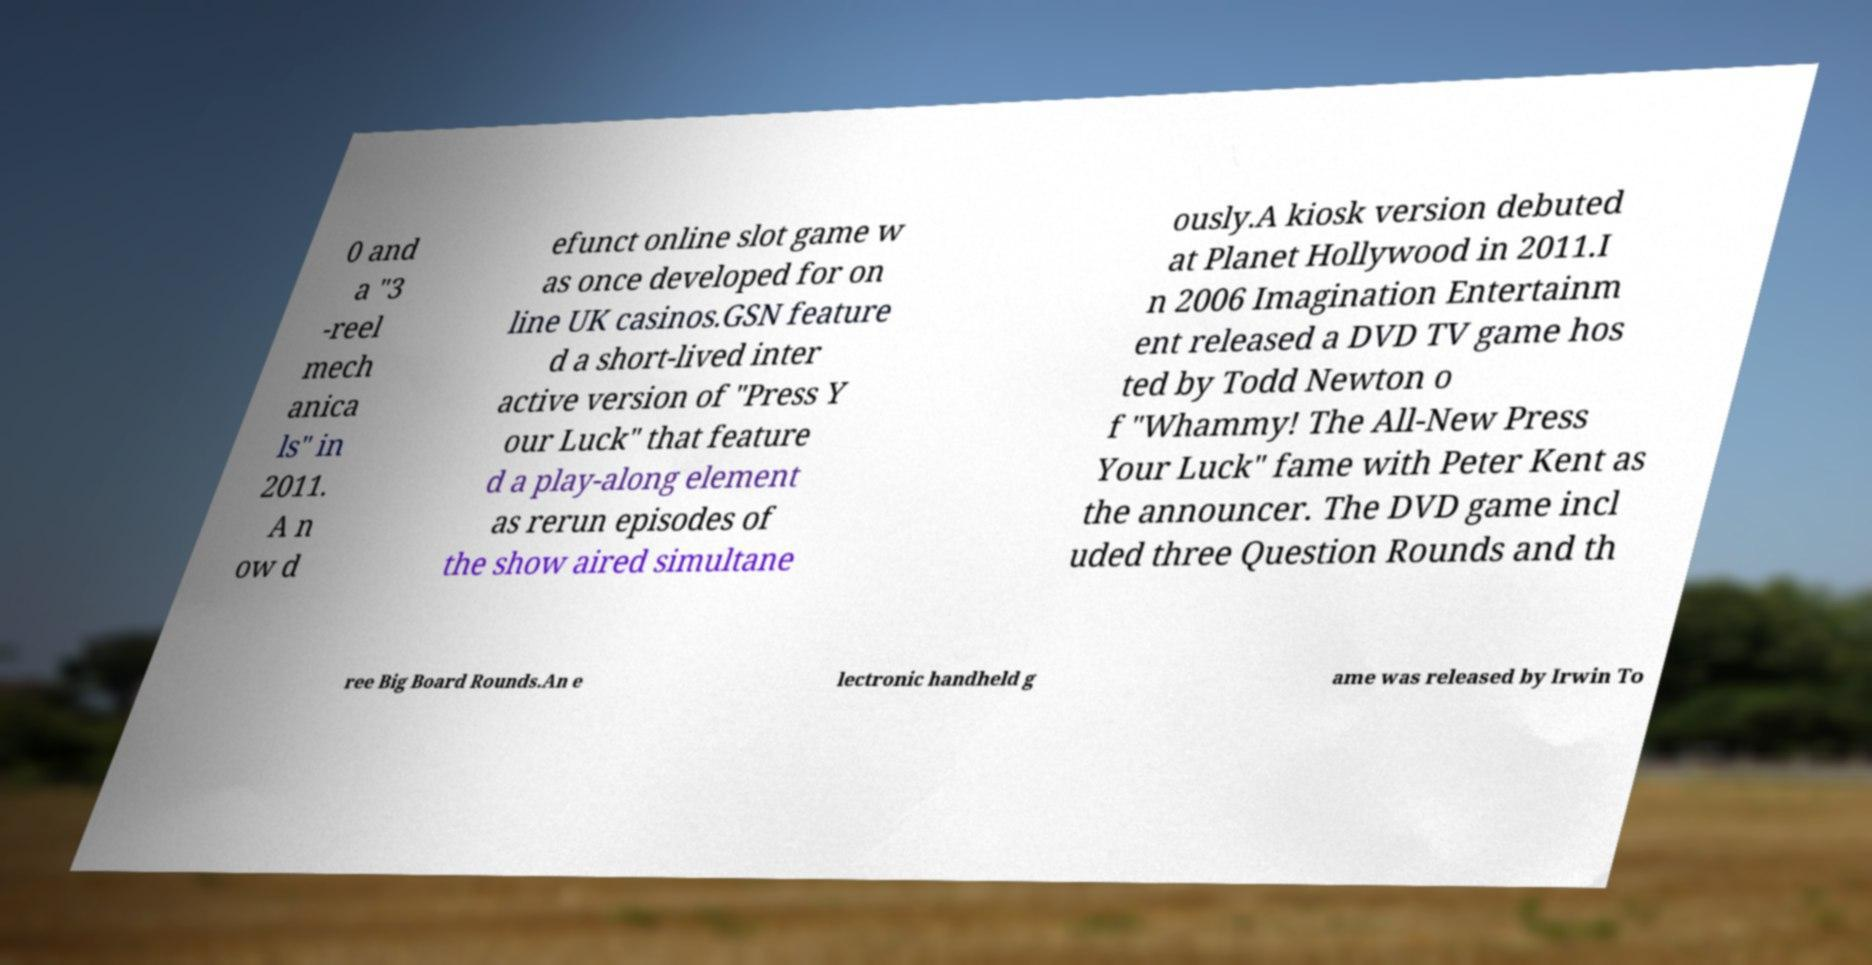Please read and relay the text visible in this image. What does it say? 0 and a "3 -reel mech anica ls" in 2011. A n ow d efunct online slot game w as once developed for on line UK casinos.GSN feature d a short-lived inter active version of "Press Y our Luck" that feature d a play-along element as rerun episodes of the show aired simultane ously.A kiosk version debuted at Planet Hollywood in 2011.I n 2006 Imagination Entertainm ent released a DVD TV game hos ted by Todd Newton o f "Whammy! The All-New Press Your Luck" fame with Peter Kent as the announcer. The DVD game incl uded three Question Rounds and th ree Big Board Rounds.An e lectronic handheld g ame was released by Irwin To 